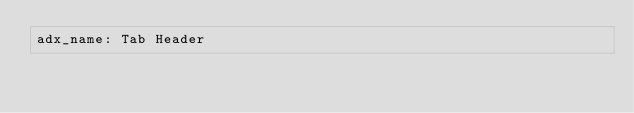Convert code to text. <code><loc_0><loc_0><loc_500><loc_500><_YAML_>adx_name: Tab Header</code> 